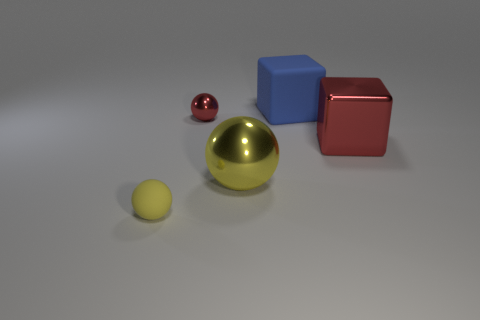How many other things are made of the same material as the tiny yellow thing?
Provide a succinct answer. 1. Is there a gray thing?
Make the answer very short. No. What is the color of the matte object that is in front of the shiny thing on the right side of the yellow thing that is right of the rubber sphere?
Make the answer very short. Yellow. Is there a large sphere that is to the right of the blue matte object behind the big yellow metallic thing?
Make the answer very short. No. Does the small sphere to the right of the small yellow matte ball have the same color as the cube in front of the large blue matte cube?
Your response must be concise. Yes. How many other rubber balls have the same size as the rubber sphere?
Offer a very short reply. 0. Do the yellow sphere to the right of the yellow rubber ball and the red shiny block have the same size?
Your answer should be compact. Yes. The big blue object is what shape?
Keep it short and to the point. Cube. The other sphere that is the same color as the rubber sphere is what size?
Offer a terse response. Large. Do the red thing right of the big yellow sphere and the big blue thing have the same material?
Your answer should be very brief. No. 